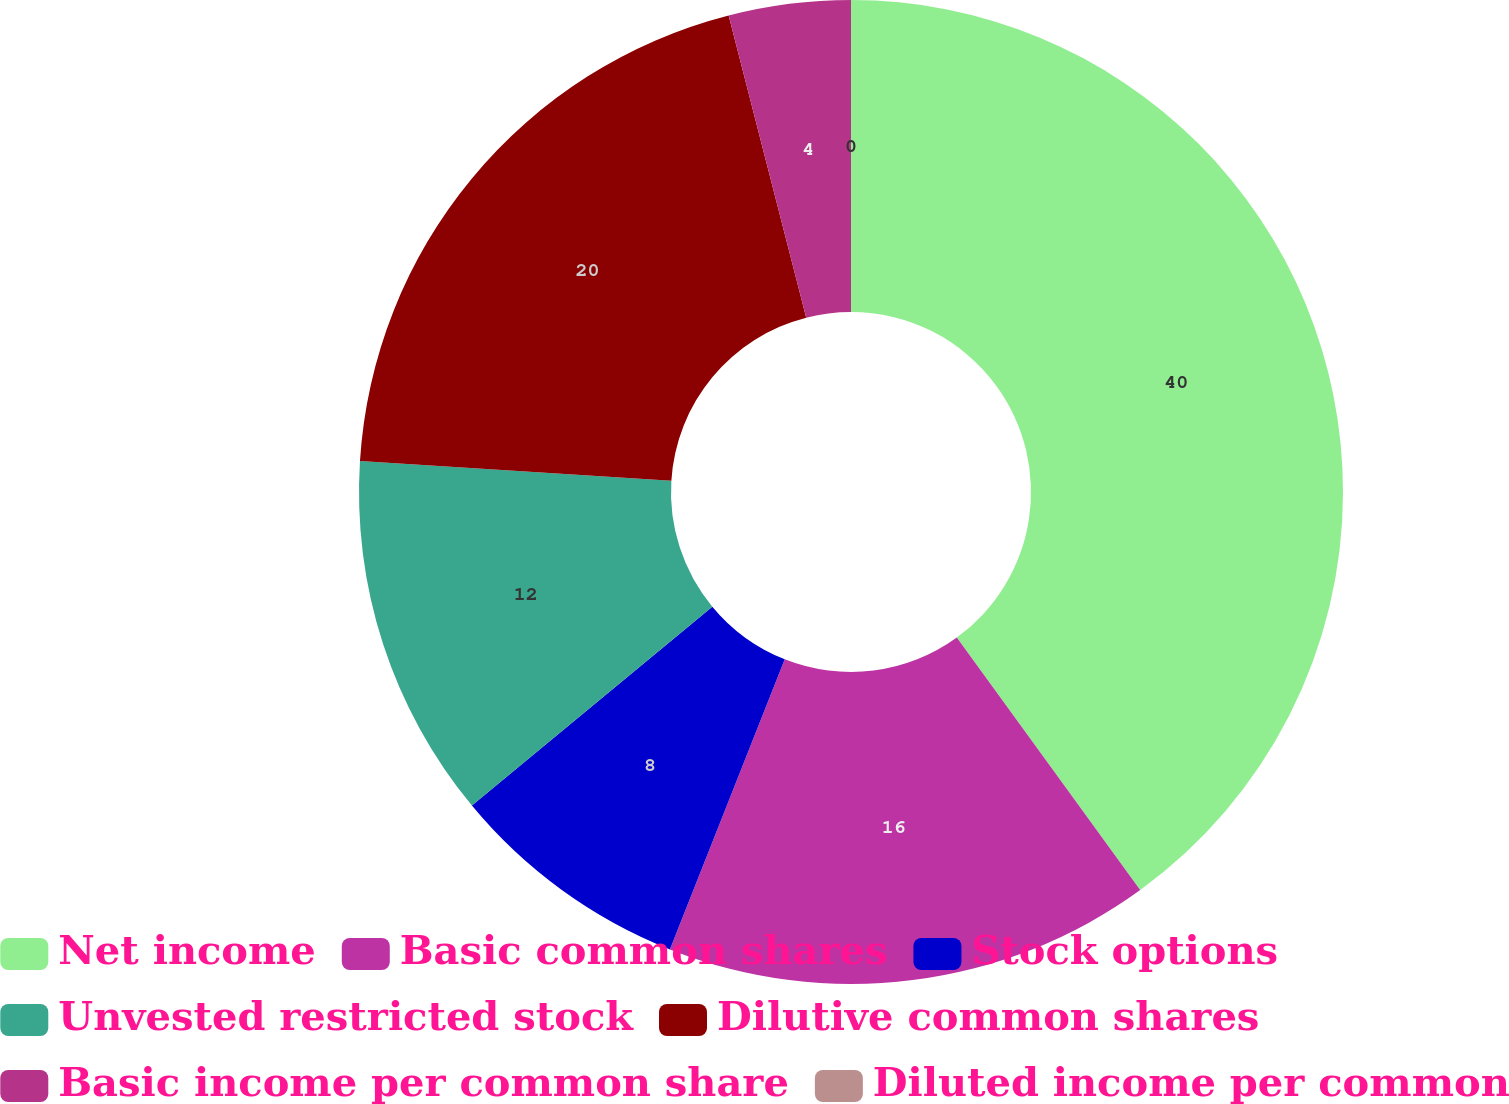<chart> <loc_0><loc_0><loc_500><loc_500><pie_chart><fcel>Net income<fcel>Basic common shares<fcel>Stock options<fcel>Unvested restricted stock<fcel>Dilutive common shares<fcel>Basic income per common share<fcel>Diluted income per common<nl><fcel>40.0%<fcel>16.0%<fcel>8.0%<fcel>12.0%<fcel>20.0%<fcel>4.0%<fcel>0.0%<nl></chart> 